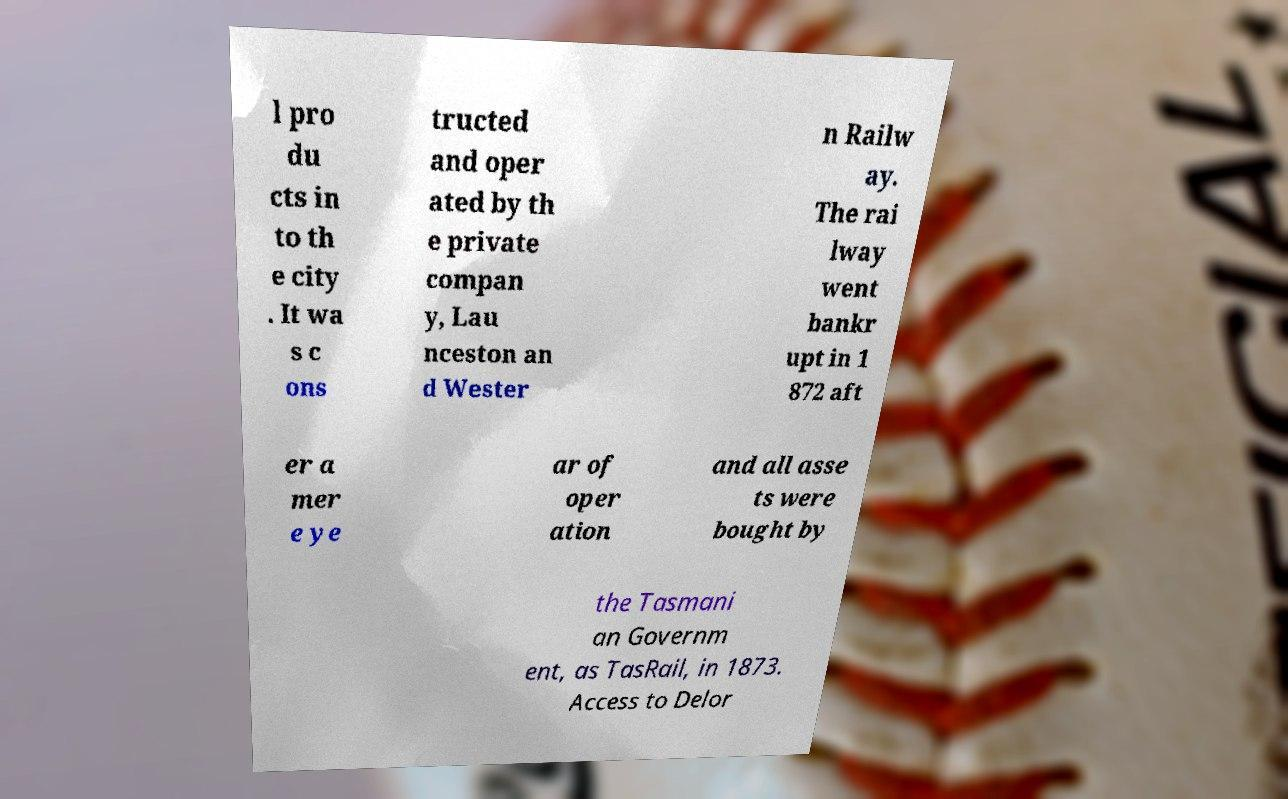Can you accurately transcribe the text from the provided image for me? l pro du cts in to th e city . It wa s c ons tructed and oper ated by th e private compan y, Lau nceston an d Wester n Railw ay. The rai lway went bankr upt in 1 872 aft er a mer e ye ar of oper ation and all asse ts were bought by the Tasmani an Governm ent, as TasRail, in 1873. Access to Delor 